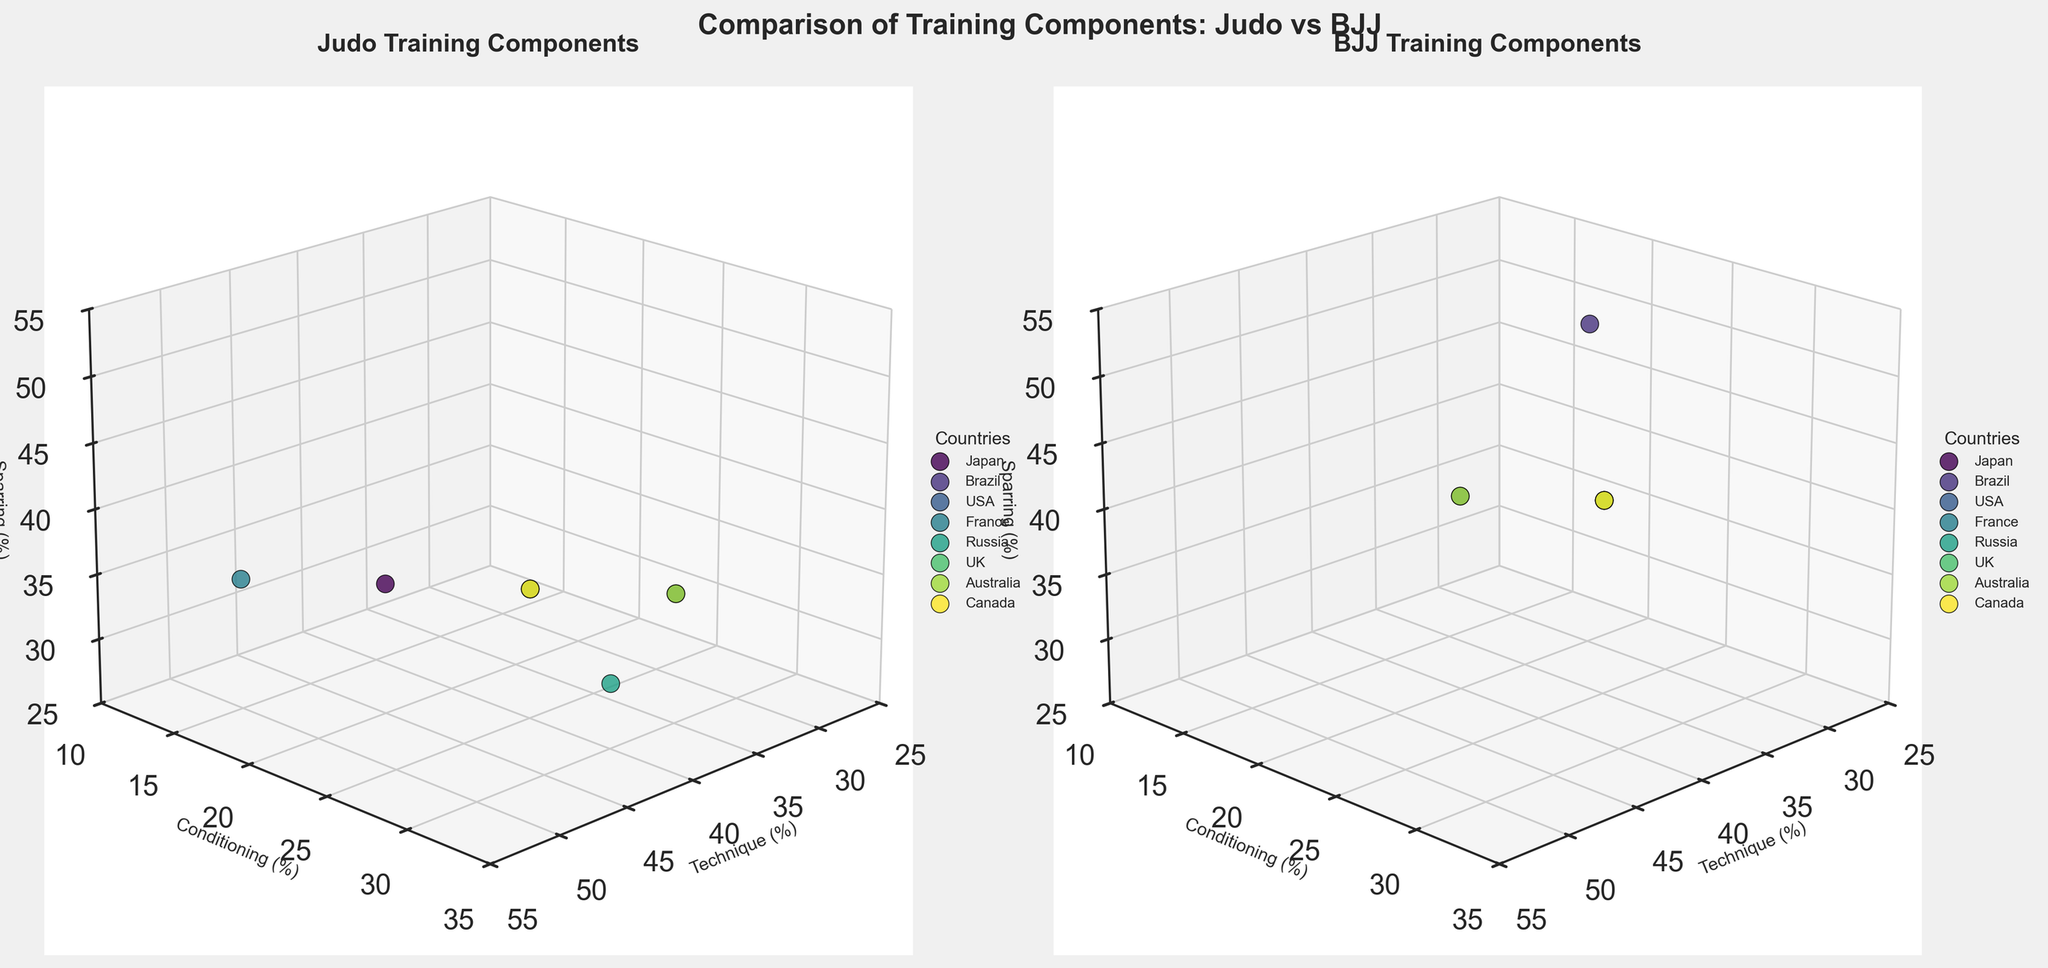what are the training components displayed on the axes for the judo plot? The judo plot has training components labeled on three axes: 'Technique (%)' on the x-axis, 'Conditioning (%)' on the y-axis, and 'Sparring (%)' on the z-axis.
Answer: Technique, Conditioning, Sparring which country dedicates the highest percentage of time to conditioning in judo? By examining the y-axis indicating 'Conditioning (%)' in the judo subplot, the country with the highest percentage of conditioning time is Russia, at 30%.
Answer: Russia how does the sparring percentage in Japan compare between judo and BJJ? For Japan, in judo, the sparring percentage is 35%, while in BJJ, it is 40%. Comparing these values, BJJ has a higher sparring percentage than judo in Japan.
Answer: BJJ has higher sparring what is the difference in conditioning time between judo and BJJ in France? In France, judo dedicates 15% to conditioning, and BJJ dedicates 25%. The difference between these values is 25% - 15% = 10%.
Answer: 10% what common trend can be observed about sparring percentages across all countries for BJJ? By inspecting the sparring percentages on the z-axis in the BJJ subplot, it is apparent that all countries have around 40% dedicated to sparring, with a slight exception for Brazil at 50%.
Answer: Generally 40% which country shows the most balanced distribution across all three components in judo? A balanced distribution would mean the percentages for technique, conditioning, and sparring are relatively close to each other. In judo, Russia has values of 40%, 30%, and 30%, which are quite balanced compared to other countries.
Answer: Russia what differences are observed in the views' azimuth and elevation angles for the subplots? Both subplots appear to have the same azimuth of 45 degrees and elevation of 20 degrees, providing a consistent viewpoint across both judo and BJJ plots.
Answer: Same (45°, 20°) are there any countries with identical training methodologies in BJJ? Observing the BJJ subplot, multiple countries including USA, France, Russia, UK, and Canada have identical values (35% Technique, 25% Conditioning, 40% Sparring).
Answer: USA, France, Russia, UK, Canada how much more time does Brazil's BJJ dedicate to sparring compared to its judo? In Brazil, BJJ has 50% for sparring, whereas judo has 35%. The difference is 50% - 35% = 15%.
Answer: 15% what percentage do techniques generally fall within among all countries in both disciplines? Observing both subplots, technique percentages for all countries in Judo generally range from 35% to 50% and similarly for BJJ.
Answer: 35% to 50% 